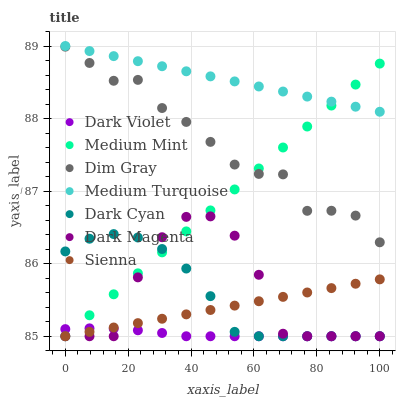Does Dark Violet have the minimum area under the curve?
Answer yes or no. Yes. Does Medium Turquoise have the maximum area under the curve?
Answer yes or no. Yes. Does Dim Gray have the minimum area under the curve?
Answer yes or no. No. Does Dim Gray have the maximum area under the curve?
Answer yes or no. No. Is Medium Mint the smoothest?
Answer yes or no. Yes. Is Dark Magenta the roughest?
Answer yes or no. Yes. Is Dim Gray the smoothest?
Answer yes or no. No. Is Dim Gray the roughest?
Answer yes or no. No. Does Medium Mint have the lowest value?
Answer yes or no. Yes. Does Dim Gray have the lowest value?
Answer yes or no. No. Does Medium Turquoise have the highest value?
Answer yes or no. Yes. Does Dim Gray have the highest value?
Answer yes or no. No. Is Dark Cyan less than Dim Gray?
Answer yes or no. Yes. Is Dim Gray greater than Dark Magenta?
Answer yes or no. Yes. Does Medium Mint intersect Dark Violet?
Answer yes or no. Yes. Is Medium Mint less than Dark Violet?
Answer yes or no. No. Is Medium Mint greater than Dark Violet?
Answer yes or no. No. Does Dark Cyan intersect Dim Gray?
Answer yes or no. No. 